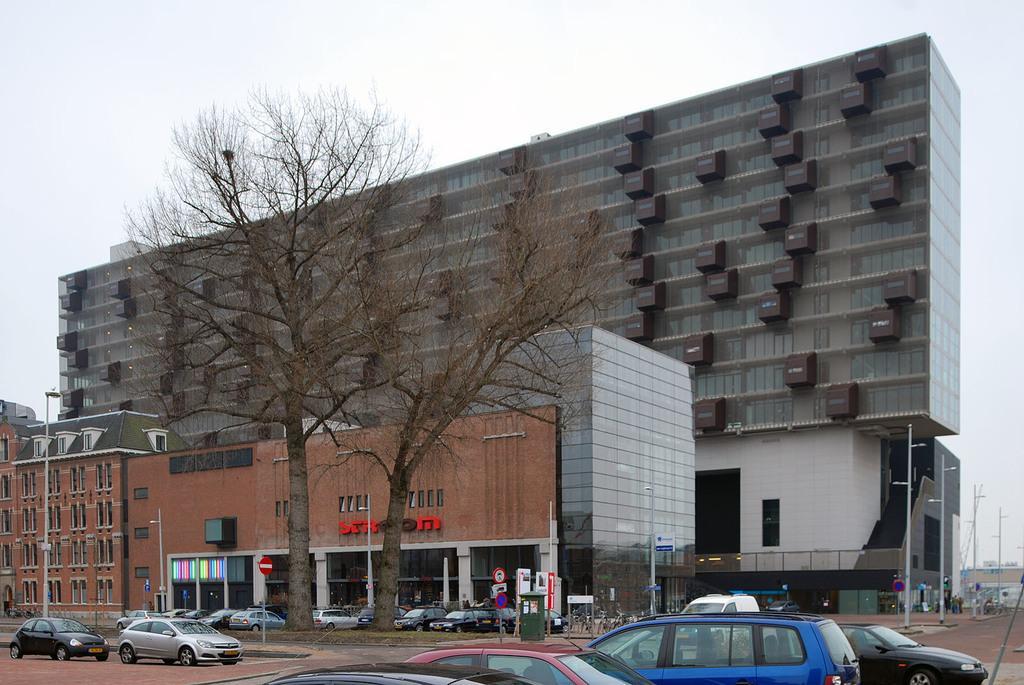Please provide a concise description of this image. There are vehicles in different colors on the road. In the background, there are poles, trees, vehicles parked, buildings and there are clouds in the sky. 